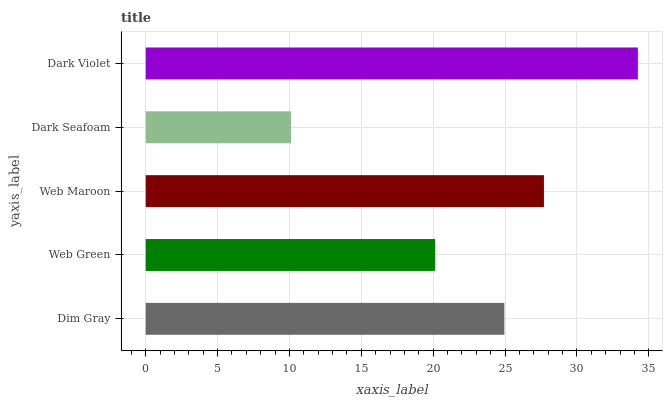Is Dark Seafoam the minimum?
Answer yes or no. Yes. Is Dark Violet the maximum?
Answer yes or no. Yes. Is Web Green the minimum?
Answer yes or no. No. Is Web Green the maximum?
Answer yes or no. No. Is Dim Gray greater than Web Green?
Answer yes or no. Yes. Is Web Green less than Dim Gray?
Answer yes or no. Yes. Is Web Green greater than Dim Gray?
Answer yes or no. No. Is Dim Gray less than Web Green?
Answer yes or no. No. Is Dim Gray the high median?
Answer yes or no. Yes. Is Dim Gray the low median?
Answer yes or no. Yes. Is Web Maroon the high median?
Answer yes or no. No. Is Web Green the low median?
Answer yes or no. No. 